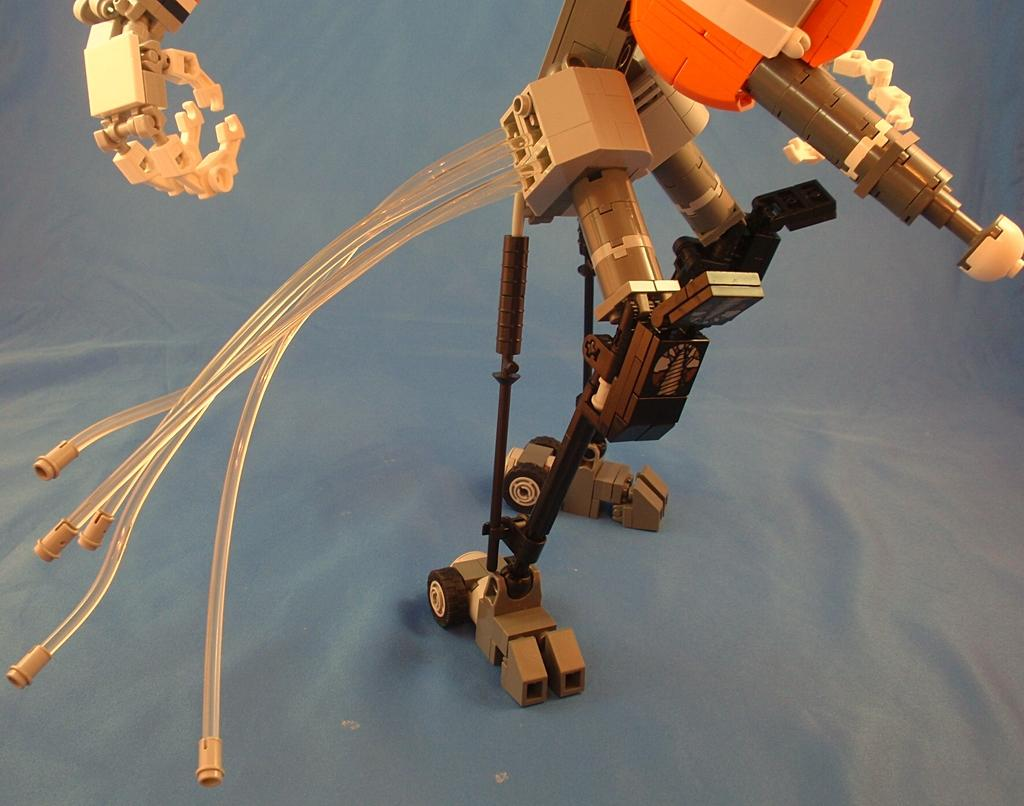What object can be seen in the image? There is a toy in the image. What color is the background at the bottom of the image? The background at the bottom of the image is grey in color. What process is being carried out by the fireman in the image? There is no fireman present in the image, so no process involving a fireman can be observed. 